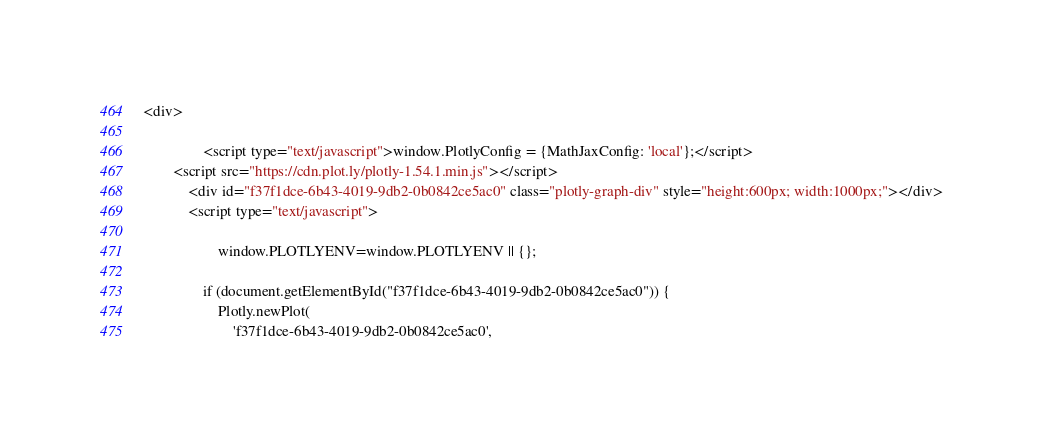<code> <loc_0><loc_0><loc_500><loc_500><_HTML_><div>
        
                <script type="text/javascript">window.PlotlyConfig = {MathJaxConfig: 'local'};</script>
        <script src="https://cdn.plot.ly/plotly-1.54.1.min.js"></script>    
            <div id="f37f1dce-6b43-4019-9db2-0b0842ce5ac0" class="plotly-graph-div" style="height:600px; width:1000px;"></div>
            <script type="text/javascript">
                
                    window.PLOTLYENV=window.PLOTLYENV || {};
                    
                if (document.getElementById("f37f1dce-6b43-4019-9db2-0b0842ce5ac0")) {
                    Plotly.newPlot(
                        'f37f1dce-6b43-4019-9db2-0b0842ce5ac0',</code> 